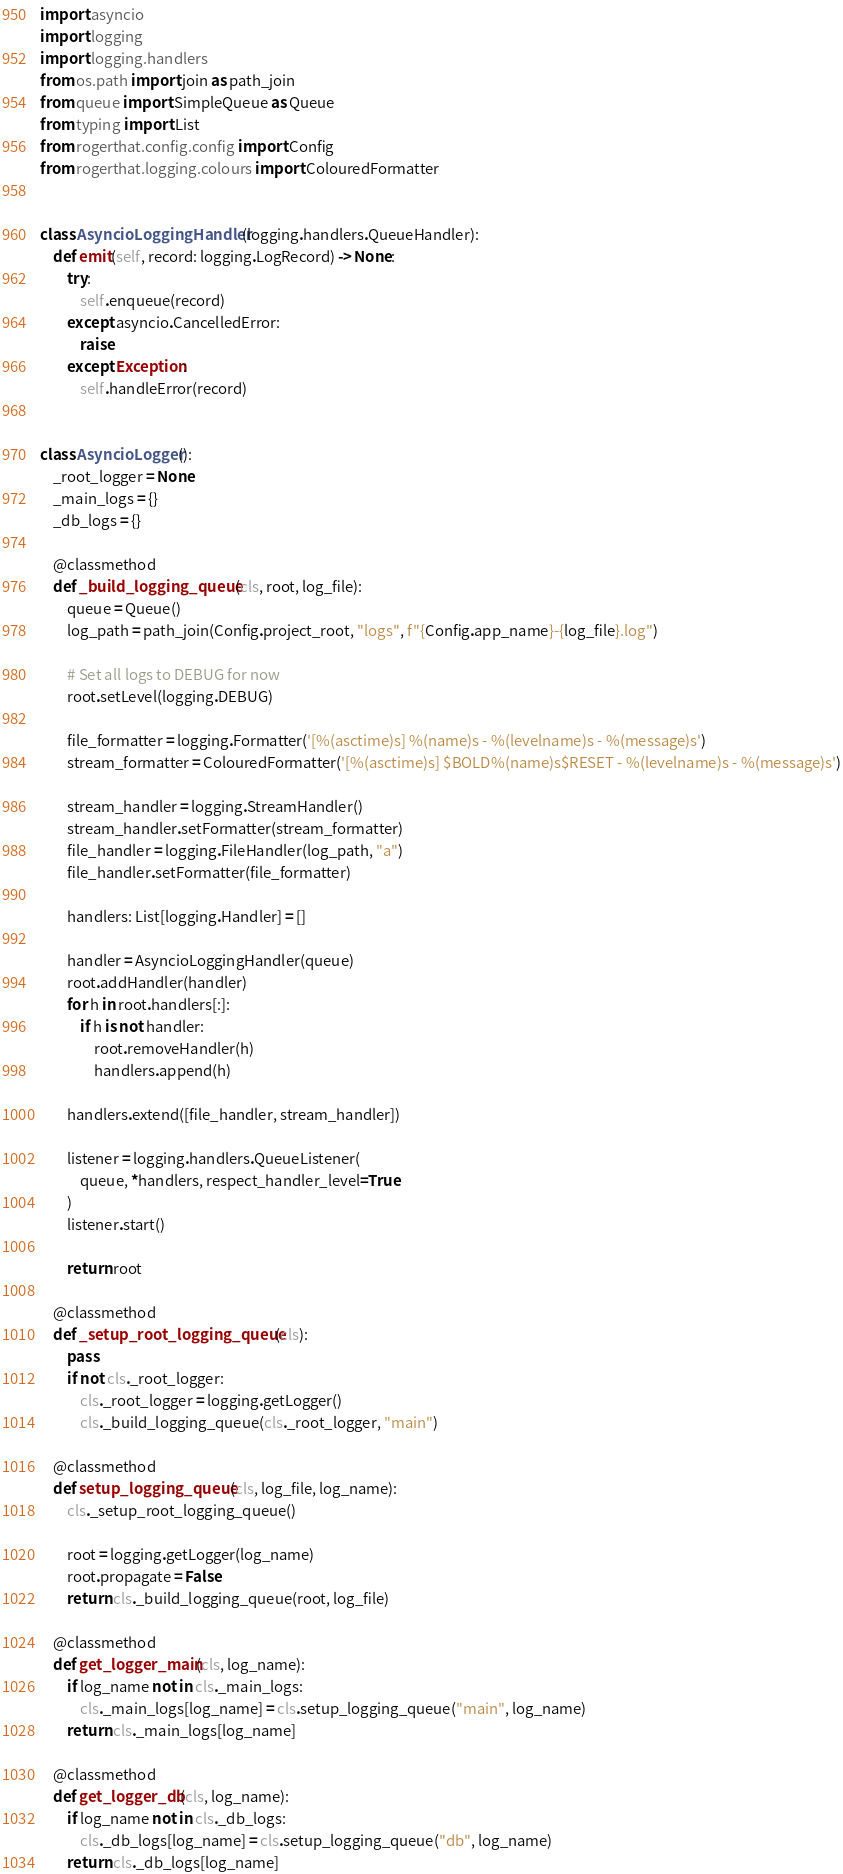<code> <loc_0><loc_0><loc_500><loc_500><_Python_>import asyncio
import logging
import logging.handlers
from os.path import join as path_join
from queue import SimpleQueue as Queue
from typing import List
from rogerthat.config.config import Config
from rogerthat.logging.colours import ColouredFormatter


class AsyncioLoggingHandler(logging.handlers.QueueHandler):
    def emit(self, record: logging.LogRecord) -> None:
        try:
            self.enqueue(record)
        except asyncio.CancelledError:
            raise
        except Exception:
            self.handleError(record)


class AsyncioLogger():
    _root_logger = None
    _main_logs = {}
    _db_logs = {}

    @classmethod
    def _build_logging_queue(cls, root, log_file):
        queue = Queue()
        log_path = path_join(Config.project_root, "logs", f"{Config.app_name}-{log_file}.log")

        # Set all logs to DEBUG for now
        root.setLevel(logging.DEBUG)

        file_formatter = logging.Formatter('[%(asctime)s] %(name)s - %(levelname)s - %(message)s')
        stream_formatter = ColouredFormatter('[%(asctime)s] $BOLD%(name)s$RESET - %(levelname)s - %(message)s')

        stream_handler = logging.StreamHandler()
        stream_handler.setFormatter(stream_formatter)
        file_handler = logging.FileHandler(log_path, "a")
        file_handler.setFormatter(file_formatter)

        handlers: List[logging.Handler] = []

        handler = AsyncioLoggingHandler(queue)
        root.addHandler(handler)
        for h in root.handlers[:]:
            if h is not handler:
                root.removeHandler(h)
                handlers.append(h)

        handlers.extend([file_handler, stream_handler])

        listener = logging.handlers.QueueListener(
            queue, *handlers, respect_handler_level=True
        )
        listener.start()

        return root

    @classmethod
    def _setup_root_logging_queue(cls):
        pass
        if not cls._root_logger:
            cls._root_logger = logging.getLogger()
            cls._build_logging_queue(cls._root_logger, "main")

    @classmethod
    def setup_logging_queue(cls, log_file, log_name):
        cls._setup_root_logging_queue()

        root = logging.getLogger(log_name)
        root.propagate = False
        return cls._build_logging_queue(root, log_file)

    @classmethod
    def get_logger_main(cls, log_name):
        if log_name not in cls._main_logs:
            cls._main_logs[log_name] = cls.setup_logging_queue("main", log_name)
        return cls._main_logs[log_name]

    @classmethod
    def get_logger_db(cls, log_name):
        if log_name not in cls._db_logs:
            cls._db_logs[log_name] = cls.setup_logging_queue("db", log_name)
        return cls._db_logs[log_name]
</code> 